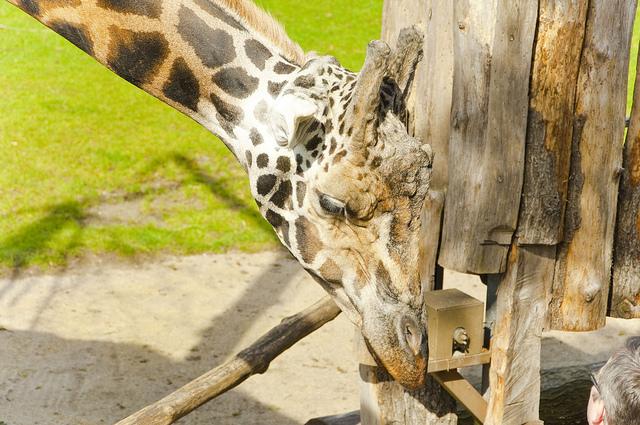What is the giraffe chewing on?
Concise answer only. Wood. What animal is this?
Give a very brief answer. Giraffe. Is the giraffe bending over a fence?
Give a very brief answer. Yes. 